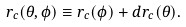<formula> <loc_0><loc_0><loc_500><loc_500>r _ { c } ( \theta , \phi ) \equiv r _ { c } ( \phi ) + d r _ { c } ( \theta ) .</formula> 